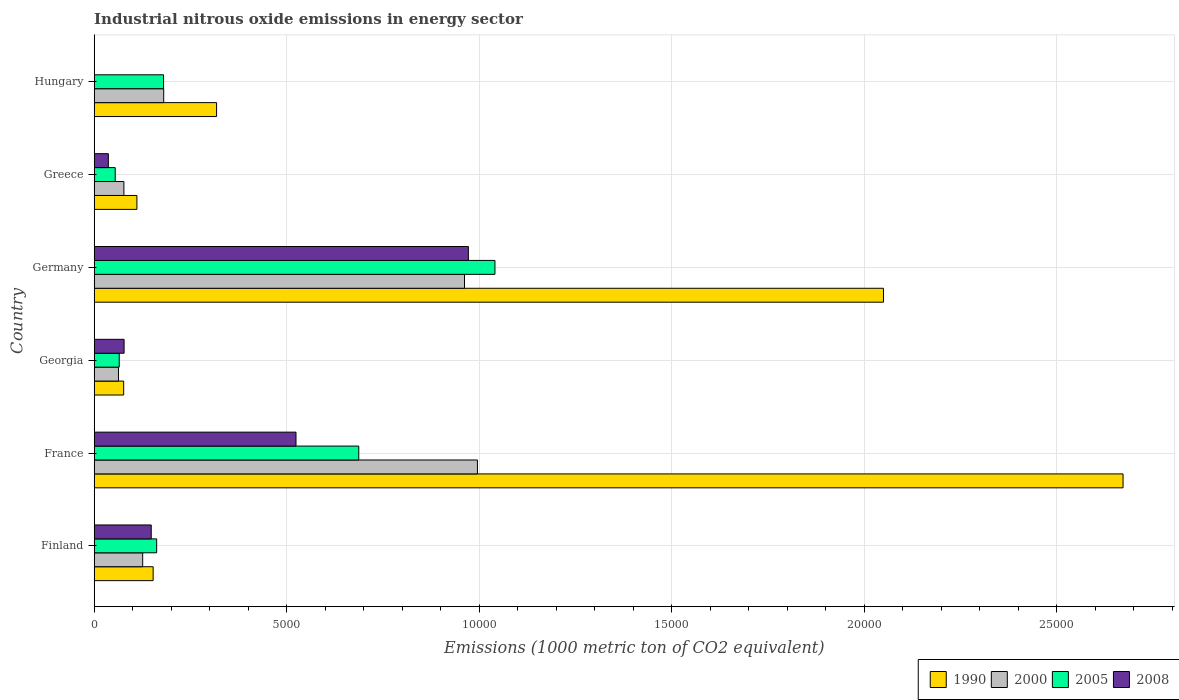Are the number of bars per tick equal to the number of legend labels?
Give a very brief answer. Yes. Are the number of bars on each tick of the Y-axis equal?
Your answer should be compact. Yes. What is the label of the 1st group of bars from the top?
Your answer should be compact. Hungary. What is the amount of industrial nitrous oxide emitted in 2005 in France?
Your answer should be compact. 6871.6. Across all countries, what is the maximum amount of industrial nitrous oxide emitted in 2008?
Make the answer very short. 9718.4. Across all countries, what is the minimum amount of industrial nitrous oxide emitted in 1990?
Provide a succinct answer. 765.3. In which country was the amount of industrial nitrous oxide emitted in 2005 maximum?
Your answer should be very brief. Germany. In which country was the amount of industrial nitrous oxide emitted in 2000 minimum?
Provide a succinct answer. Georgia. What is the total amount of industrial nitrous oxide emitted in 2005 in the graph?
Give a very brief answer. 2.19e+04. What is the difference between the amount of industrial nitrous oxide emitted in 2005 in Georgia and that in Greece?
Provide a short and direct response. 104.3. What is the difference between the amount of industrial nitrous oxide emitted in 2008 in Greece and the amount of industrial nitrous oxide emitted in 1990 in Finland?
Offer a very short reply. -1163.5. What is the average amount of industrial nitrous oxide emitted in 2000 per country?
Make the answer very short. 4006.33. What is the difference between the amount of industrial nitrous oxide emitted in 2005 and amount of industrial nitrous oxide emitted in 2008 in Finland?
Provide a short and direct response. 140.9. In how many countries, is the amount of industrial nitrous oxide emitted in 2005 greater than 26000 1000 metric ton?
Provide a short and direct response. 0. What is the ratio of the amount of industrial nitrous oxide emitted in 2008 in Finland to that in Germany?
Your response must be concise. 0.15. What is the difference between the highest and the second highest amount of industrial nitrous oxide emitted in 1990?
Give a very brief answer. 6222.7. What is the difference between the highest and the lowest amount of industrial nitrous oxide emitted in 2000?
Ensure brevity in your answer.  9323.3. What does the 2nd bar from the top in Greece represents?
Your answer should be very brief. 2005. Is it the case that in every country, the sum of the amount of industrial nitrous oxide emitted in 2005 and amount of industrial nitrous oxide emitted in 2000 is greater than the amount of industrial nitrous oxide emitted in 2008?
Your response must be concise. Yes. How many bars are there?
Offer a terse response. 24. How many countries are there in the graph?
Offer a very short reply. 6. What is the difference between two consecutive major ticks on the X-axis?
Keep it short and to the point. 5000. Does the graph contain any zero values?
Your answer should be very brief. No. Does the graph contain grids?
Provide a succinct answer. Yes. How many legend labels are there?
Your response must be concise. 4. What is the title of the graph?
Offer a terse response. Industrial nitrous oxide emissions in energy sector. What is the label or title of the X-axis?
Keep it short and to the point. Emissions (1000 metric ton of CO2 equivalent). What is the label or title of the Y-axis?
Ensure brevity in your answer.  Country. What is the Emissions (1000 metric ton of CO2 equivalent) in 1990 in Finland?
Your answer should be very brief. 1530.9. What is the Emissions (1000 metric ton of CO2 equivalent) in 2000 in Finland?
Provide a succinct answer. 1259.4. What is the Emissions (1000 metric ton of CO2 equivalent) in 2005 in Finland?
Give a very brief answer. 1622.4. What is the Emissions (1000 metric ton of CO2 equivalent) in 2008 in Finland?
Make the answer very short. 1481.5. What is the Emissions (1000 metric ton of CO2 equivalent) in 1990 in France?
Your response must be concise. 2.67e+04. What is the Emissions (1000 metric ton of CO2 equivalent) of 2000 in France?
Make the answer very short. 9953.8. What is the Emissions (1000 metric ton of CO2 equivalent) of 2005 in France?
Your response must be concise. 6871.6. What is the Emissions (1000 metric ton of CO2 equivalent) of 2008 in France?
Your answer should be compact. 5241.3. What is the Emissions (1000 metric ton of CO2 equivalent) in 1990 in Georgia?
Make the answer very short. 765.3. What is the Emissions (1000 metric ton of CO2 equivalent) in 2000 in Georgia?
Keep it short and to the point. 630.5. What is the Emissions (1000 metric ton of CO2 equivalent) of 2005 in Georgia?
Your response must be concise. 650.1. What is the Emissions (1000 metric ton of CO2 equivalent) of 2008 in Georgia?
Keep it short and to the point. 776.5. What is the Emissions (1000 metric ton of CO2 equivalent) of 1990 in Germany?
Your answer should be very brief. 2.05e+04. What is the Emissions (1000 metric ton of CO2 equivalent) in 2000 in Germany?
Offer a very short reply. 9617.9. What is the Emissions (1000 metric ton of CO2 equivalent) of 2005 in Germany?
Ensure brevity in your answer.  1.04e+04. What is the Emissions (1000 metric ton of CO2 equivalent) in 2008 in Germany?
Your answer should be compact. 9718.4. What is the Emissions (1000 metric ton of CO2 equivalent) in 1990 in Greece?
Keep it short and to the point. 1109.1. What is the Emissions (1000 metric ton of CO2 equivalent) of 2000 in Greece?
Give a very brief answer. 771. What is the Emissions (1000 metric ton of CO2 equivalent) in 2005 in Greece?
Offer a terse response. 545.8. What is the Emissions (1000 metric ton of CO2 equivalent) in 2008 in Greece?
Your answer should be very brief. 367.4. What is the Emissions (1000 metric ton of CO2 equivalent) of 1990 in Hungary?
Your answer should be compact. 3178.6. What is the Emissions (1000 metric ton of CO2 equivalent) of 2000 in Hungary?
Provide a short and direct response. 1805.4. What is the Emissions (1000 metric ton of CO2 equivalent) in 2005 in Hungary?
Your answer should be compact. 1802. What is the Emissions (1000 metric ton of CO2 equivalent) of 2008 in Hungary?
Give a very brief answer. 6. Across all countries, what is the maximum Emissions (1000 metric ton of CO2 equivalent) in 1990?
Provide a succinct answer. 2.67e+04. Across all countries, what is the maximum Emissions (1000 metric ton of CO2 equivalent) in 2000?
Provide a succinct answer. 9953.8. Across all countries, what is the maximum Emissions (1000 metric ton of CO2 equivalent) in 2005?
Make the answer very short. 1.04e+04. Across all countries, what is the maximum Emissions (1000 metric ton of CO2 equivalent) in 2008?
Make the answer very short. 9718.4. Across all countries, what is the minimum Emissions (1000 metric ton of CO2 equivalent) of 1990?
Provide a short and direct response. 765.3. Across all countries, what is the minimum Emissions (1000 metric ton of CO2 equivalent) of 2000?
Ensure brevity in your answer.  630.5. Across all countries, what is the minimum Emissions (1000 metric ton of CO2 equivalent) of 2005?
Your answer should be compact. 545.8. What is the total Emissions (1000 metric ton of CO2 equivalent) of 1990 in the graph?
Your response must be concise. 5.38e+04. What is the total Emissions (1000 metric ton of CO2 equivalent) of 2000 in the graph?
Provide a short and direct response. 2.40e+04. What is the total Emissions (1000 metric ton of CO2 equivalent) of 2005 in the graph?
Your response must be concise. 2.19e+04. What is the total Emissions (1000 metric ton of CO2 equivalent) in 2008 in the graph?
Ensure brevity in your answer.  1.76e+04. What is the difference between the Emissions (1000 metric ton of CO2 equivalent) in 1990 in Finland and that in France?
Make the answer very short. -2.52e+04. What is the difference between the Emissions (1000 metric ton of CO2 equivalent) of 2000 in Finland and that in France?
Give a very brief answer. -8694.4. What is the difference between the Emissions (1000 metric ton of CO2 equivalent) in 2005 in Finland and that in France?
Your answer should be very brief. -5249.2. What is the difference between the Emissions (1000 metric ton of CO2 equivalent) in 2008 in Finland and that in France?
Provide a succinct answer. -3759.8. What is the difference between the Emissions (1000 metric ton of CO2 equivalent) of 1990 in Finland and that in Georgia?
Ensure brevity in your answer.  765.6. What is the difference between the Emissions (1000 metric ton of CO2 equivalent) in 2000 in Finland and that in Georgia?
Provide a short and direct response. 628.9. What is the difference between the Emissions (1000 metric ton of CO2 equivalent) in 2005 in Finland and that in Georgia?
Offer a very short reply. 972.3. What is the difference between the Emissions (1000 metric ton of CO2 equivalent) of 2008 in Finland and that in Georgia?
Offer a very short reply. 705. What is the difference between the Emissions (1000 metric ton of CO2 equivalent) in 1990 in Finland and that in Germany?
Your response must be concise. -1.90e+04. What is the difference between the Emissions (1000 metric ton of CO2 equivalent) of 2000 in Finland and that in Germany?
Ensure brevity in your answer.  -8358.5. What is the difference between the Emissions (1000 metric ton of CO2 equivalent) of 2005 in Finland and that in Germany?
Your answer should be very brief. -8786.5. What is the difference between the Emissions (1000 metric ton of CO2 equivalent) in 2008 in Finland and that in Germany?
Provide a short and direct response. -8236.9. What is the difference between the Emissions (1000 metric ton of CO2 equivalent) in 1990 in Finland and that in Greece?
Offer a very short reply. 421.8. What is the difference between the Emissions (1000 metric ton of CO2 equivalent) of 2000 in Finland and that in Greece?
Make the answer very short. 488.4. What is the difference between the Emissions (1000 metric ton of CO2 equivalent) of 2005 in Finland and that in Greece?
Provide a short and direct response. 1076.6. What is the difference between the Emissions (1000 metric ton of CO2 equivalent) in 2008 in Finland and that in Greece?
Your response must be concise. 1114.1. What is the difference between the Emissions (1000 metric ton of CO2 equivalent) of 1990 in Finland and that in Hungary?
Provide a succinct answer. -1647.7. What is the difference between the Emissions (1000 metric ton of CO2 equivalent) of 2000 in Finland and that in Hungary?
Provide a succinct answer. -546. What is the difference between the Emissions (1000 metric ton of CO2 equivalent) in 2005 in Finland and that in Hungary?
Give a very brief answer. -179.6. What is the difference between the Emissions (1000 metric ton of CO2 equivalent) in 2008 in Finland and that in Hungary?
Your answer should be very brief. 1475.5. What is the difference between the Emissions (1000 metric ton of CO2 equivalent) of 1990 in France and that in Georgia?
Offer a very short reply. 2.60e+04. What is the difference between the Emissions (1000 metric ton of CO2 equivalent) of 2000 in France and that in Georgia?
Make the answer very short. 9323.3. What is the difference between the Emissions (1000 metric ton of CO2 equivalent) in 2005 in France and that in Georgia?
Make the answer very short. 6221.5. What is the difference between the Emissions (1000 metric ton of CO2 equivalent) in 2008 in France and that in Georgia?
Your answer should be very brief. 4464.8. What is the difference between the Emissions (1000 metric ton of CO2 equivalent) in 1990 in France and that in Germany?
Your answer should be very brief. 6222.7. What is the difference between the Emissions (1000 metric ton of CO2 equivalent) in 2000 in France and that in Germany?
Your answer should be compact. 335.9. What is the difference between the Emissions (1000 metric ton of CO2 equivalent) of 2005 in France and that in Germany?
Keep it short and to the point. -3537.3. What is the difference between the Emissions (1000 metric ton of CO2 equivalent) in 2008 in France and that in Germany?
Make the answer very short. -4477.1. What is the difference between the Emissions (1000 metric ton of CO2 equivalent) in 1990 in France and that in Greece?
Ensure brevity in your answer.  2.56e+04. What is the difference between the Emissions (1000 metric ton of CO2 equivalent) of 2000 in France and that in Greece?
Ensure brevity in your answer.  9182.8. What is the difference between the Emissions (1000 metric ton of CO2 equivalent) of 2005 in France and that in Greece?
Keep it short and to the point. 6325.8. What is the difference between the Emissions (1000 metric ton of CO2 equivalent) in 2008 in France and that in Greece?
Offer a very short reply. 4873.9. What is the difference between the Emissions (1000 metric ton of CO2 equivalent) in 1990 in France and that in Hungary?
Your answer should be very brief. 2.35e+04. What is the difference between the Emissions (1000 metric ton of CO2 equivalent) of 2000 in France and that in Hungary?
Keep it short and to the point. 8148.4. What is the difference between the Emissions (1000 metric ton of CO2 equivalent) of 2005 in France and that in Hungary?
Your response must be concise. 5069.6. What is the difference between the Emissions (1000 metric ton of CO2 equivalent) in 2008 in France and that in Hungary?
Offer a very short reply. 5235.3. What is the difference between the Emissions (1000 metric ton of CO2 equivalent) of 1990 in Georgia and that in Germany?
Give a very brief answer. -1.97e+04. What is the difference between the Emissions (1000 metric ton of CO2 equivalent) of 2000 in Georgia and that in Germany?
Provide a succinct answer. -8987.4. What is the difference between the Emissions (1000 metric ton of CO2 equivalent) of 2005 in Georgia and that in Germany?
Offer a very short reply. -9758.8. What is the difference between the Emissions (1000 metric ton of CO2 equivalent) in 2008 in Georgia and that in Germany?
Give a very brief answer. -8941.9. What is the difference between the Emissions (1000 metric ton of CO2 equivalent) in 1990 in Georgia and that in Greece?
Your response must be concise. -343.8. What is the difference between the Emissions (1000 metric ton of CO2 equivalent) in 2000 in Georgia and that in Greece?
Give a very brief answer. -140.5. What is the difference between the Emissions (1000 metric ton of CO2 equivalent) in 2005 in Georgia and that in Greece?
Ensure brevity in your answer.  104.3. What is the difference between the Emissions (1000 metric ton of CO2 equivalent) in 2008 in Georgia and that in Greece?
Your answer should be compact. 409.1. What is the difference between the Emissions (1000 metric ton of CO2 equivalent) in 1990 in Georgia and that in Hungary?
Your answer should be compact. -2413.3. What is the difference between the Emissions (1000 metric ton of CO2 equivalent) in 2000 in Georgia and that in Hungary?
Make the answer very short. -1174.9. What is the difference between the Emissions (1000 metric ton of CO2 equivalent) of 2005 in Georgia and that in Hungary?
Offer a terse response. -1151.9. What is the difference between the Emissions (1000 metric ton of CO2 equivalent) of 2008 in Georgia and that in Hungary?
Provide a short and direct response. 770.5. What is the difference between the Emissions (1000 metric ton of CO2 equivalent) of 1990 in Germany and that in Greece?
Offer a very short reply. 1.94e+04. What is the difference between the Emissions (1000 metric ton of CO2 equivalent) of 2000 in Germany and that in Greece?
Your answer should be very brief. 8846.9. What is the difference between the Emissions (1000 metric ton of CO2 equivalent) of 2005 in Germany and that in Greece?
Ensure brevity in your answer.  9863.1. What is the difference between the Emissions (1000 metric ton of CO2 equivalent) in 2008 in Germany and that in Greece?
Your response must be concise. 9351. What is the difference between the Emissions (1000 metric ton of CO2 equivalent) of 1990 in Germany and that in Hungary?
Ensure brevity in your answer.  1.73e+04. What is the difference between the Emissions (1000 metric ton of CO2 equivalent) in 2000 in Germany and that in Hungary?
Your response must be concise. 7812.5. What is the difference between the Emissions (1000 metric ton of CO2 equivalent) of 2005 in Germany and that in Hungary?
Your answer should be very brief. 8606.9. What is the difference between the Emissions (1000 metric ton of CO2 equivalent) in 2008 in Germany and that in Hungary?
Provide a succinct answer. 9712.4. What is the difference between the Emissions (1000 metric ton of CO2 equivalent) in 1990 in Greece and that in Hungary?
Make the answer very short. -2069.5. What is the difference between the Emissions (1000 metric ton of CO2 equivalent) in 2000 in Greece and that in Hungary?
Provide a succinct answer. -1034.4. What is the difference between the Emissions (1000 metric ton of CO2 equivalent) of 2005 in Greece and that in Hungary?
Provide a short and direct response. -1256.2. What is the difference between the Emissions (1000 metric ton of CO2 equivalent) of 2008 in Greece and that in Hungary?
Provide a short and direct response. 361.4. What is the difference between the Emissions (1000 metric ton of CO2 equivalent) in 1990 in Finland and the Emissions (1000 metric ton of CO2 equivalent) in 2000 in France?
Keep it short and to the point. -8422.9. What is the difference between the Emissions (1000 metric ton of CO2 equivalent) of 1990 in Finland and the Emissions (1000 metric ton of CO2 equivalent) of 2005 in France?
Ensure brevity in your answer.  -5340.7. What is the difference between the Emissions (1000 metric ton of CO2 equivalent) in 1990 in Finland and the Emissions (1000 metric ton of CO2 equivalent) in 2008 in France?
Ensure brevity in your answer.  -3710.4. What is the difference between the Emissions (1000 metric ton of CO2 equivalent) of 2000 in Finland and the Emissions (1000 metric ton of CO2 equivalent) of 2005 in France?
Your answer should be very brief. -5612.2. What is the difference between the Emissions (1000 metric ton of CO2 equivalent) in 2000 in Finland and the Emissions (1000 metric ton of CO2 equivalent) in 2008 in France?
Your answer should be compact. -3981.9. What is the difference between the Emissions (1000 metric ton of CO2 equivalent) of 2005 in Finland and the Emissions (1000 metric ton of CO2 equivalent) of 2008 in France?
Your response must be concise. -3618.9. What is the difference between the Emissions (1000 metric ton of CO2 equivalent) of 1990 in Finland and the Emissions (1000 metric ton of CO2 equivalent) of 2000 in Georgia?
Offer a terse response. 900.4. What is the difference between the Emissions (1000 metric ton of CO2 equivalent) in 1990 in Finland and the Emissions (1000 metric ton of CO2 equivalent) in 2005 in Georgia?
Your response must be concise. 880.8. What is the difference between the Emissions (1000 metric ton of CO2 equivalent) in 1990 in Finland and the Emissions (1000 metric ton of CO2 equivalent) in 2008 in Georgia?
Your response must be concise. 754.4. What is the difference between the Emissions (1000 metric ton of CO2 equivalent) in 2000 in Finland and the Emissions (1000 metric ton of CO2 equivalent) in 2005 in Georgia?
Your answer should be compact. 609.3. What is the difference between the Emissions (1000 metric ton of CO2 equivalent) of 2000 in Finland and the Emissions (1000 metric ton of CO2 equivalent) of 2008 in Georgia?
Keep it short and to the point. 482.9. What is the difference between the Emissions (1000 metric ton of CO2 equivalent) in 2005 in Finland and the Emissions (1000 metric ton of CO2 equivalent) in 2008 in Georgia?
Provide a succinct answer. 845.9. What is the difference between the Emissions (1000 metric ton of CO2 equivalent) in 1990 in Finland and the Emissions (1000 metric ton of CO2 equivalent) in 2000 in Germany?
Offer a terse response. -8087. What is the difference between the Emissions (1000 metric ton of CO2 equivalent) in 1990 in Finland and the Emissions (1000 metric ton of CO2 equivalent) in 2005 in Germany?
Ensure brevity in your answer.  -8878. What is the difference between the Emissions (1000 metric ton of CO2 equivalent) of 1990 in Finland and the Emissions (1000 metric ton of CO2 equivalent) of 2008 in Germany?
Give a very brief answer. -8187.5. What is the difference between the Emissions (1000 metric ton of CO2 equivalent) in 2000 in Finland and the Emissions (1000 metric ton of CO2 equivalent) in 2005 in Germany?
Provide a succinct answer. -9149.5. What is the difference between the Emissions (1000 metric ton of CO2 equivalent) in 2000 in Finland and the Emissions (1000 metric ton of CO2 equivalent) in 2008 in Germany?
Your answer should be very brief. -8459. What is the difference between the Emissions (1000 metric ton of CO2 equivalent) in 2005 in Finland and the Emissions (1000 metric ton of CO2 equivalent) in 2008 in Germany?
Provide a succinct answer. -8096. What is the difference between the Emissions (1000 metric ton of CO2 equivalent) of 1990 in Finland and the Emissions (1000 metric ton of CO2 equivalent) of 2000 in Greece?
Ensure brevity in your answer.  759.9. What is the difference between the Emissions (1000 metric ton of CO2 equivalent) of 1990 in Finland and the Emissions (1000 metric ton of CO2 equivalent) of 2005 in Greece?
Offer a very short reply. 985.1. What is the difference between the Emissions (1000 metric ton of CO2 equivalent) of 1990 in Finland and the Emissions (1000 metric ton of CO2 equivalent) of 2008 in Greece?
Your answer should be compact. 1163.5. What is the difference between the Emissions (1000 metric ton of CO2 equivalent) in 2000 in Finland and the Emissions (1000 metric ton of CO2 equivalent) in 2005 in Greece?
Your response must be concise. 713.6. What is the difference between the Emissions (1000 metric ton of CO2 equivalent) of 2000 in Finland and the Emissions (1000 metric ton of CO2 equivalent) of 2008 in Greece?
Provide a succinct answer. 892. What is the difference between the Emissions (1000 metric ton of CO2 equivalent) of 2005 in Finland and the Emissions (1000 metric ton of CO2 equivalent) of 2008 in Greece?
Keep it short and to the point. 1255. What is the difference between the Emissions (1000 metric ton of CO2 equivalent) in 1990 in Finland and the Emissions (1000 metric ton of CO2 equivalent) in 2000 in Hungary?
Offer a terse response. -274.5. What is the difference between the Emissions (1000 metric ton of CO2 equivalent) of 1990 in Finland and the Emissions (1000 metric ton of CO2 equivalent) of 2005 in Hungary?
Your response must be concise. -271.1. What is the difference between the Emissions (1000 metric ton of CO2 equivalent) in 1990 in Finland and the Emissions (1000 metric ton of CO2 equivalent) in 2008 in Hungary?
Provide a short and direct response. 1524.9. What is the difference between the Emissions (1000 metric ton of CO2 equivalent) of 2000 in Finland and the Emissions (1000 metric ton of CO2 equivalent) of 2005 in Hungary?
Your response must be concise. -542.6. What is the difference between the Emissions (1000 metric ton of CO2 equivalent) of 2000 in Finland and the Emissions (1000 metric ton of CO2 equivalent) of 2008 in Hungary?
Offer a terse response. 1253.4. What is the difference between the Emissions (1000 metric ton of CO2 equivalent) in 2005 in Finland and the Emissions (1000 metric ton of CO2 equivalent) in 2008 in Hungary?
Your answer should be compact. 1616.4. What is the difference between the Emissions (1000 metric ton of CO2 equivalent) in 1990 in France and the Emissions (1000 metric ton of CO2 equivalent) in 2000 in Georgia?
Your response must be concise. 2.61e+04. What is the difference between the Emissions (1000 metric ton of CO2 equivalent) of 1990 in France and the Emissions (1000 metric ton of CO2 equivalent) of 2005 in Georgia?
Provide a short and direct response. 2.61e+04. What is the difference between the Emissions (1000 metric ton of CO2 equivalent) in 1990 in France and the Emissions (1000 metric ton of CO2 equivalent) in 2008 in Georgia?
Provide a short and direct response. 2.59e+04. What is the difference between the Emissions (1000 metric ton of CO2 equivalent) in 2000 in France and the Emissions (1000 metric ton of CO2 equivalent) in 2005 in Georgia?
Keep it short and to the point. 9303.7. What is the difference between the Emissions (1000 metric ton of CO2 equivalent) of 2000 in France and the Emissions (1000 metric ton of CO2 equivalent) of 2008 in Georgia?
Your answer should be very brief. 9177.3. What is the difference between the Emissions (1000 metric ton of CO2 equivalent) of 2005 in France and the Emissions (1000 metric ton of CO2 equivalent) of 2008 in Georgia?
Your response must be concise. 6095.1. What is the difference between the Emissions (1000 metric ton of CO2 equivalent) of 1990 in France and the Emissions (1000 metric ton of CO2 equivalent) of 2000 in Germany?
Your response must be concise. 1.71e+04. What is the difference between the Emissions (1000 metric ton of CO2 equivalent) in 1990 in France and the Emissions (1000 metric ton of CO2 equivalent) in 2005 in Germany?
Offer a very short reply. 1.63e+04. What is the difference between the Emissions (1000 metric ton of CO2 equivalent) in 1990 in France and the Emissions (1000 metric ton of CO2 equivalent) in 2008 in Germany?
Your response must be concise. 1.70e+04. What is the difference between the Emissions (1000 metric ton of CO2 equivalent) of 2000 in France and the Emissions (1000 metric ton of CO2 equivalent) of 2005 in Germany?
Offer a very short reply. -455.1. What is the difference between the Emissions (1000 metric ton of CO2 equivalent) of 2000 in France and the Emissions (1000 metric ton of CO2 equivalent) of 2008 in Germany?
Give a very brief answer. 235.4. What is the difference between the Emissions (1000 metric ton of CO2 equivalent) of 2005 in France and the Emissions (1000 metric ton of CO2 equivalent) of 2008 in Germany?
Offer a terse response. -2846.8. What is the difference between the Emissions (1000 metric ton of CO2 equivalent) in 1990 in France and the Emissions (1000 metric ton of CO2 equivalent) in 2000 in Greece?
Keep it short and to the point. 2.60e+04. What is the difference between the Emissions (1000 metric ton of CO2 equivalent) of 1990 in France and the Emissions (1000 metric ton of CO2 equivalent) of 2005 in Greece?
Your answer should be compact. 2.62e+04. What is the difference between the Emissions (1000 metric ton of CO2 equivalent) of 1990 in France and the Emissions (1000 metric ton of CO2 equivalent) of 2008 in Greece?
Make the answer very short. 2.64e+04. What is the difference between the Emissions (1000 metric ton of CO2 equivalent) of 2000 in France and the Emissions (1000 metric ton of CO2 equivalent) of 2005 in Greece?
Ensure brevity in your answer.  9408. What is the difference between the Emissions (1000 metric ton of CO2 equivalent) of 2000 in France and the Emissions (1000 metric ton of CO2 equivalent) of 2008 in Greece?
Your answer should be compact. 9586.4. What is the difference between the Emissions (1000 metric ton of CO2 equivalent) of 2005 in France and the Emissions (1000 metric ton of CO2 equivalent) of 2008 in Greece?
Provide a short and direct response. 6504.2. What is the difference between the Emissions (1000 metric ton of CO2 equivalent) in 1990 in France and the Emissions (1000 metric ton of CO2 equivalent) in 2000 in Hungary?
Your response must be concise. 2.49e+04. What is the difference between the Emissions (1000 metric ton of CO2 equivalent) in 1990 in France and the Emissions (1000 metric ton of CO2 equivalent) in 2005 in Hungary?
Your answer should be very brief. 2.49e+04. What is the difference between the Emissions (1000 metric ton of CO2 equivalent) in 1990 in France and the Emissions (1000 metric ton of CO2 equivalent) in 2008 in Hungary?
Your answer should be very brief. 2.67e+04. What is the difference between the Emissions (1000 metric ton of CO2 equivalent) of 2000 in France and the Emissions (1000 metric ton of CO2 equivalent) of 2005 in Hungary?
Offer a very short reply. 8151.8. What is the difference between the Emissions (1000 metric ton of CO2 equivalent) of 2000 in France and the Emissions (1000 metric ton of CO2 equivalent) of 2008 in Hungary?
Provide a short and direct response. 9947.8. What is the difference between the Emissions (1000 metric ton of CO2 equivalent) of 2005 in France and the Emissions (1000 metric ton of CO2 equivalent) of 2008 in Hungary?
Your answer should be compact. 6865.6. What is the difference between the Emissions (1000 metric ton of CO2 equivalent) of 1990 in Georgia and the Emissions (1000 metric ton of CO2 equivalent) of 2000 in Germany?
Your answer should be compact. -8852.6. What is the difference between the Emissions (1000 metric ton of CO2 equivalent) of 1990 in Georgia and the Emissions (1000 metric ton of CO2 equivalent) of 2005 in Germany?
Ensure brevity in your answer.  -9643.6. What is the difference between the Emissions (1000 metric ton of CO2 equivalent) of 1990 in Georgia and the Emissions (1000 metric ton of CO2 equivalent) of 2008 in Germany?
Offer a terse response. -8953.1. What is the difference between the Emissions (1000 metric ton of CO2 equivalent) in 2000 in Georgia and the Emissions (1000 metric ton of CO2 equivalent) in 2005 in Germany?
Ensure brevity in your answer.  -9778.4. What is the difference between the Emissions (1000 metric ton of CO2 equivalent) in 2000 in Georgia and the Emissions (1000 metric ton of CO2 equivalent) in 2008 in Germany?
Give a very brief answer. -9087.9. What is the difference between the Emissions (1000 metric ton of CO2 equivalent) in 2005 in Georgia and the Emissions (1000 metric ton of CO2 equivalent) in 2008 in Germany?
Your answer should be compact. -9068.3. What is the difference between the Emissions (1000 metric ton of CO2 equivalent) in 1990 in Georgia and the Emissions (1000 metric ton of CO2 equivalent) in 2000 in Greece?
Ensure brevity in your answer.  -5.7. What is the difference between the Emissions (1000 metric ton of CO2 equivalent) in 1990 in Georgia and the Emissions (1000 metric ton of CO2 equivalent) in 2005 in Greece?
Keep it short and to the point. 219.5. What is the difference between the Emissions (1000 metric ton of CO2 equivalent) in 1990 in Georgia and the Emissions (1000 metric ton of CO2 equivalent) in 2008 in Greece?
Offer a very short reply. 397.9. What is the difference between the Emissions (1000 metric ton of CO2 equivalent) of 2000 in Georgia and the Emissions (1000 metric ton of CO2 equivalent) of 2005 in Greece?
Your answer should be very brief. 84.7. What is the difference between the Emissions (1000 metric ton of CO2 equivalent) of 2000 in Georgia and the Emissions (1000 metric ton of CO2 equivalent) of 2008 in Greece?
Keep it short and to the point. 263.1. What is the difference between the Emissions (1000 metric ton of CO2 equivalent) of 2005 in Georgia and the Emissions (1000 metric ton of CO2 equivalent) of 2008 in Greece?
Offer a very short reply. 282.7. What is the difference between the Emissions (1000 metric ton of CO2 equivalent) of 1990 in Georgia and the Emissions (1000 metric ton of CO2 equivalent) of 2000 in Hungary?
Your answer should be very brief. -1040.1. What is the difference between the Emissions (1000 metric ton of CO2 equivalent) in 1990 in Georgia and the Emissions (1000 metric ton of CO2 equivalent) in 2005 in Hungary?
Keep it short and to the point. -1036.7. What is the difference between the Emissions (1000 metric ton of CO2 equivalent) of 1990 in Georgia and the Emissions (1000 metric ton of CO2 equivalent) of 2008 in Hungary?
Make the answer very short. 759.3. What is the difference between the Emissions (1000 metric ton of CO2 equivalent) of 2000 in Georgia and the Emissions (1000 metric ton of CO2 equivalent) of 2005 in Hungary?
Provide a succinct answer. -1171.5. What is the difference between the Emissions (1000 metric ton of CO2 equivalent) in 2000 in Georgia and the Emissions (1000 metric ton of CO2 equivalent) in 2008 in Hungary?
Your answer should be compact. 624.5. What is the difference between the Emissions (1000 metric ton of CO2 equivalent) in 2005 in Georgia and the Emissions (1000 metric ton of CO2 equivalent) in 2008 in Hungary?
Offer a very short reply. 644.1. What is the difference between the Emissions (1000 metric ton of CO2 equivalent) in 1990 in Germany and the Emissions (1000 metric ton of CO2 equivalent) in 2000 in Greece?
Provide a succinct answer. 1.97e+04. What is the difference between the Emissions (1000 metric ton of CO2 equivalent) in 1990 in Germany and the Emissions (1000 metric ton of CO2 equivalent) in 2005 in Greece?
Keep it short and to the point. 2.00e+04. What is the difference between the Emissions (1000 metric ton of CO2 equivalent) in 1990 in Germany and the Emissions (1000 metric ton of CO2 equivalent) in 2008 in Greece?
Ensure brevity in your answer.  2.01e+04. What is the difference between the Emissions (1000 metric ton of CO2 equivalent) in 2000 in Germany and the Emissions (1000 metric ton of CO2 equivalent) in 2005 in Greece?
Offer a very short reply. 9072.1. What is the difference between the Emissions (1000 metric ton of CO2 equivalent) in 2000 in Germany and the Emissions (1000 metric ton of CO2 equivalent) in 2008 in Greece?
Ensure brevity in your answer.  9250.5. What is the difference between the Emissions (1000 metric ton of CO2 equivalent) of 2005 in Germany and the Emissions (1000 metric ton of CO2 equivalent) of 2008 in Greece?
Provide a short and direct response. 1.00e+04. What is the difference between the Emissions (1000 metric ton of CO2 equivalent) of 1990 in Germany and the Emissions (1000 metric ton of CO2 equivalent) of 2000 in Hungary?
Provide a succinct answer. 1.87e+04. What is the difference between the Emissions (1000 metric ton of CO2 equivalent) in 1990 in Germany and the Emissions (1000 metric ton of CO2 equivalent) in 2005 in Hungary?
Your response must be concise. 1.87e+04. What is the difference between the Emissions (1000 metric ton of CO2 equivalent) in 1990 in Germany and the Emissions (1000 metric ton of CO2 equivalent) in 2008 in Hungary?
Offer a very short reply. 2.05e+04. What is the difference between the Emissions (1000 metric ton of CO2 equivalent) in 2000 in Germany and the Emissions (1000 metric ton of CO2 equivalent) in 2005 in Hungary?
Keep it short and to the point. 7815.9. What is the difference between the Emissions (1000 metric ton of CO2 equivalent) in 2000 in Germany and the Emissions (1000 metric ton of CO2 equivalent) in 2008 in Hungary?
Provide a succinct answer. 9611.9. What is the difference between the Emissions (1000 metric ton of CO2 equivalent) in 2005 in Germany and the Emissions (1000 metric ton of CO2 equivalent) in 2008 in Hungary?
Your answer should be compact. 1.04e+04. What is the difference between the Emissions (1000 metric ton of CO2 equivalent) in 1990 in Greece and the Emissions (1000 metric ton of CO2 equivalent) in 2000 in Hungary?
Your answer should be very brief. -696.3. What is the difference between the Emissions (1000 metric ton of CO2 equivalent) in 1990 in Greece and the Emissions (1000 metric ton of CO2 equivalent) in 2005 in Hungary?
Your answer should be compact. -692.9. What is the difference between the Emissions (1000 metric ton of CO2 equivalent) of 1990 in Greece and the Emissions (1000 metric ton of CO2 equivalent) of 2008 in Hungary?
Make the answer very short. 1103.1. What is the difference between the Emissions (1000 metric ton of CO2 equivalent) of 2000 in Greece and the Emissions (1000 metric ton of CO2 equivalent) of 2005 in Hungary?
Your response must be concise. -1031. What is the difference between the Emissions (1000 metric ton of CO2 equivalent) in 2000 in Greece and the Emissions (1000 metric ton of CO2 equivalent) in 2008 in Hungary?
Offer a terse response. 765. What is the difference between the Emissions (1000 metric ton of CO2 equivalent) of 2005 in Greece and the Emissions (1000 metric ton of CO2 equivalent) of 2008 in Hungary?
Give a very brief answer. 539.8. What is the average Emissions (1000 metric ton of CO2 equivalent) in 1990 per country?
Your answer should be compact. 8967.63. What is the average Emissions (1000 metric ton of CO2 equivalent) in 2000 per country?
Your answer should be compact. 4006.33. What is the average Emissions (1000 metric ton of CO2 equivalent) of 2005 per country?
Give a very brief answer. 3650.13. What is the average Emissions (1000 metric ton of CO2 equivalent) in 2008 per country?
Offer a terse response. 2931.85. What is the difference between the Emissions (1000 metric ton of CO2 equivalent) of 1990 and Emissions (1000 metric ton of CO2 equivalent) of 2000 in Finland?
Provide a short and direct response. 271.5. What is the difference between the Emissions (1000 metric ton of CO2 equivalent) of 1990 and Emissions (1000 metric ton of CO2 equivalent) of 2005 in Finland?
Your answer should be very brief. -91.5. What is the difference between the Emissions (1000 metric ton of CO2 equivalent) of 1990 and Emissions (1000 metric ton of CO2 equivalent) of 2008 in Finland?
Keep it short and to the point. 49.4. What is the difference between the Emissions (1000 metric ton of CO2 equivalent) in 2000 and Emissions (1000 metric ton of CO2 equivalent) in 2005 in Finland?
Give a very brief answer. -363. What is the difference between the Emissions (1000 metric ton of CO2 equivalent) of 2000 and Emissions (1000 metric ton of CO2 equivalent) of 2008 in Finland?
Offer a terse response. -222.1. What is the difference between the Emissions (1000 metric ton of CO2 equivalent) of 2005 and Emissions (1000 metric ton of CO2 equivalent) of 2008 in Finland?
Your response must be concise. 140.9. What is the difference between the Emissions (1000 metric ton of CO2 equivalent) of 1990 and Emissions (1000 metric ton of CO2 equivalent) of 2000 in France?
Make the answer very short. 1.68e+04. What is the difference between the Emissions (1000 metric ton of CO2 equivalent) in 1990 and Emissions (1000 metric ton of CO2 equivalent) in 2005 in France?
Your answer should be compact. 1.99e+04. What is the difference between the Emissions (1000 metric ton of CO2 equivalent) in 1990 and Emissions (1000 metric ton of CO2 equivalent) in 2008 in France?
Make the answer very short. 2.15e+04. What is the difference between the Emissions (1000 metric ton of CO2 equivalent) in 2000 and Emissions (1000 metric ton of CO2 equivalent) in 2005 in France?
Offer a very short reply. 3082.2. What is the difference between the Emissions (1000 metric ton of CO2 equivalent) in 2000 and Emissions (1000 metric ton of CO2 equivalent) in 2008 in France?
Make the answer very short. 4712.5. What is the difference between the Emissions (1000 metric ton of CO2 equivalent) in 2005 and Emissions (1000 metric ton of CO2 equivalent) in 2008 in France?
Offer a very short reply. 1630.3. What is the difference between the Emissions (1000 metric ton of CO2 equivalent) of 1990 and Emissions (1000 metric ton of CO2 equivalent) of 2000 in Georgia?
Provide a succinct answer. 134.8. What is the difference between the Emissions (1000 metric ton of CO2 equivalent) in 1990 and Emissions (1000 metric ton of CO2 equivalent) in 2005 in Georgia?
Make the answer very short. 115.2. What is the difference between the Emissions (1000 metric ton of CO2 equivalent) in 1990 and Emissions (1000 metric ton of CO2 equivalent) in 2008 in Georgia?
Your response must be concise. -11.2. What is the difference between the Emissions (1000 metric ton of CO2 equivalent) of 2000 and Emissions (1000 metric ton of CO2 equivalent) of 2005 in Georgia?
Your response must be concise. -19.6. What is the difference between the Emissions (1000 metric ton of CO2 equivalent) of 2000 and Emissions (1000 metric ton of CO2 equivalent) of 2008 in Georgia?
Your answer should be compact. -146. What is the difference between the Emissions (1000 metric ton of CO2 equivalent) of 2005 and Emissions (1000 metric ton of CO2 equivalent) of 2008 in Georgia?
Offer a very short reply. -126.4. What is the difference between the Emissions (1000 metric ton of CO2 equivalent) in 1990 and Emissions (1000 metric ton of CO2 equivalent) in 2000 in Germany?
Offer a terse response. 1.09e+04. What is the difference between the Emissions (1000 metric ton of CO2 equivalent) of 1990 and Emissions (1000 metric ton of CO2 equivalent) of 2005 in Germany?
Keep it short and to the point. 1.01e+04. What is the difference between the Emissions (1000 metric ton of CO2 equivalent) in 1990 and Emissions (1000 metric ton of CO2 equivalent) in 2008 in Germany?
Your answer should be compact. 1.08e+04. What is the difference between the Emissions (1000 metric ton of CO2 equivalent) of 2000 and Emissions (1000 metric ton of CO2 equivalent) of 2005 in Germany?
Keep it short and to the point. -791. What is the difference between the Emissions (1000 metric ton of CO2 equivalent) of 2000 and Emissions (1000 metric ton of CO2 equivalent) of 2008 in Germany?
Your answer should be compact. -100.5. What is the difference between the Emissions (1000 metric ton of CO2 equivalent) of 2005 and Emissions (1000 metric ton of CO2 equivalent) of 2008 in Germany?
Offer a terse response. 690.5. What is the difference between the Emissions (1000 metric ton of CO2 equivalent) in 1990 and Emissions (1000 metric ton of CO2 equivalent) in 2000 in Greece?
Your response must be concise. 338.1. What is the difference between the Emissions (1000 metric ton of CO2 equivalent) of 1990 and Emissions (1000 metric ton of CO2 equivalent) of 2005 in Greece?
Ensure brevity in your answer.  563.3. What is the difference between the Emissions (1000 metric ton of CO2 equivalent) of 1990 and Emissions (1000 metric ton of CO2 equivalent) of 2008 in Greece?
Make the answer very short. 741.7. What is the difference between the Emissions (1000 metric ton of CO2 equivalent) in 2000 and Emissions (1000 metric ton of CO2 equivalent) in 2005 in Greece?
Your response must be concise. 225.2. What is the difference between the Emissions (1000 metric ton of CO2 equivalent) of 2000 and Emissions (1000 metric ton of CO2 equivalent) of 2008 in Greece?
Your response must be concise. 403.6. What is the difference between the Emissions (1000 metric ton of CO2 equivalent) in 2005 and Emissions (1000 metric ton of CO2 equivalent) in 2008 in Greece?
Offer a terse response. 178.4. What is the difference between the Emissions (1000 metric ton of CO2 equivalent) of 1990 and Emissions (1000 metric ton of CO2 equivalent) of 2000 in Hungary?
Keep it short and to the point. 1373.2. What is the difference between the Emissions (1000 metric ton of CO2 equivalent) in 1990 and Emissions (1000 metric ton of CO2 equivalent) in 2005 in Hungary?
Provide a short and direct response. 1376.6. What is the difference between the Emissions (1000 metric ton of CO2 equivalent) in 1990 and Emissions (1000 metric ton of CO2 equivalent) in 2008 in Hungary?
Offer a terse response. 3172.6. What is the difference between the Emissions (1000 metric ton of CO2 equivalent) in 2000 and Emissions (1000 metric ton of CO2 equivalent) in 2005 in Hungary?
Your response must be concise. 3.4. What is the difference between the Emissions (1000 metric ton of CO2 equivalent) in 2000 and Emissions (1000 metric ton of CO2 equivalent) in 2008 in Hungary?
Provide a short and direct response. 1799.4. What is the difference between the Emissions (1000 metric ton of CO2 equivalent) of 2005 and Emissions (1000 metric ton of CO2 equivalent) of 2008 in Hungary?
Keep it short and to the point. 1796. What is the ratio of the Emissions (1000 metric ton of CO2 equivalent) in 1990 in Finland to that in France?
Offer a very short reply. 0.06. What is the ratio of the Emissions (1000 metric ton of CO2 equivalent) in 2000 in Finland to that in France?
Ensure brevity in your answer.  0.13. What is the ratio of the Emissions (1000 metric ton of CO2 equivalent) of 2005 in Finland to that in France?
Your response must be concise. 0.24. What is the ratio of the Emissions (1000 metric ton of CO2 equivalent) in 2008 in Finland to that in France?
Offer a very short reply. 0.28. What is the ratio of the Emissions (1000 metric ton of CO2 equivalent) in 1990 in Finland to that in Georgia?
Provide a short and direct response. 2. What is the ratio of the Emissions (1000 metric ton of CO2 equivalent) of 2000 in Finland to that in Georgia?
Your response must be concise. 2. What is the ratio of the Emissions (1000 metric ton of CO2 equivalent) in 2005 in Finland to that in Georgia?
Provide a succinct answer. 2.5. What is the ratio of the Emissions (1000 metric ton of CO2 equivalent) in 2008 in Finland to that in Georgia?
Your response must be concise. 1.91. What is the ratio of the Emissions (1000 metric ton of CO2 equivalent) in 1990 in Finland to that in Germany?
Keep it short and to the point. 0.07. What is the ratio of the Emissions (1000 metric ton of CO2 equivalent) of 2000 in Finland to that in Germany?
Provide a short and direct response. 0.13. What is the ratio of the Emissions (1000 metric ton of CO2 equivalent) of 2005 in Finland to that in Germany?
Ensure brevity in your answer.  0.16. What is the ratio of the Emissions (1000 metric ton of CO2 equivalent) of 2008 in Finland to that in Germany?
Your answer should be compact. 0.15. What is the ratio of the Emissions (1000 metric ton of CO2 equivalent) of 1990 in Finland to that in Greece?
Make the answer very short. 1.38. What is the ratio of the Emissions (1000 metric ton of CO2 equivalent) of 2000 in Finland to that in Greece?
Make the answer very short. 1.63. What is the ratio of the Emissions (1000 metric ton of CO2 equivalent) of 2005 in Finland to that in Greece?
Ensure brevity in your answer.  2.97. What is the ratio of the Emissions (1000 metric ton of CO2 equivalent) in 2008 in Finland to that in Greece?
Your response must be concise. 4.03. What is the ratio of the Emissions (1000 metric ton of CO2 equivalent) in 1990 in Finland to that in Hungary?
Offer a terse response. 0.48. What is the ratio of the Emissions (1000 metric ton of CO2 equivalent) of 2000 in Finland to that in Hungary?
Your answer should be very brief. 0.7. What is the ratio of the Emissions (1000 metric ton of CO2 equivalent) in 2005 in Finland to that in Hungary?
Offer a very short reply. 0.9. What is the ratio of the Emissions (1000 metric ton of CO2 equivalent) of 2008 in Finland to that in Hungary?
Provide a short and direct response. 246.92. What is the ratio of the Emissions (1000 metric ton of CO2 equivalent) of 1990 in France to that in Georgia?
Provide a succinct answer. 34.92. What is the ratio of the Emissions (1000 metric ton of CO2 equivalent) of 2000 in France to that in Georgia?
Offer a terse response. 15.79. What is the ratio of the Emissions (1000 metric ton of CO2 equivalent) in 2005 in France to that in Georgia?
Your answer should be compact. 10.57. What is the ratio of the Emissions (1000 metric ton of CO2 equivalent) of 2008 in France to that in Georgia?
Your answer should be very brief. 6.75. What is the ratio of the Emissions (1000 metric ton of CO2 equivalent) in 1990 in France to that in Germany?
Offer a terse response. 1.3. What is the ratio of the Emissions (1000 metric ton of CO2 equivalent) in 2000 in France to that in Germany?
Keep it short and to the point. 1.03. What is the ratio of the Emissions (1000 metric ton of CO2 equivalent) of 2005 in France to that in Germany?
Your response must be concise. 0.66. What is the ratio of the Emissions (1000 metric ton of CO2 equivalent) in 2008 in France to that in Germany?
Offer a very short reply. 0.54. What is the ratio of the Emissions (1000 metric ton of CO2 equivalent) of 1990 in France to that in Greece?
Your answer should be very brief. 24.09. What is the ratio of the Emissions (1000 metric ton of CO2 equivalent) of 2000 in France to that in Greece?
Provide a succinct answer. 12.91. What is the ratio of the Emissions (1000 metric ton of CO2 equivalent) in 2005 in France to that in Greece?
Ensure brevity in your answer.  12.59. What is the ratio of the Emissions (1000 metric ton of CO2 equivalent) of 2008 in France to that in Greece?
Provide a short and direct response. 14.27. What is the ratio of the Emissions (1000 metric ton of CO2 equivalent) in 1990 in France to that in Hungary?
Your answer should be very brief. 8.41. What is the ratio of the Emissions (1000 metric ton of CO2 equivalent) of 2000 in France to that in Hungary?
Your answer should be very brief. 5.51. What is the ratio of the Emissions (1000 metric ton of CO2 equivalent) in 2005 in France to that in Hungary?
Provide a succinct answer. 3.81. What is the ratio of the Emissions (1000 metric ton of CO2 equivalent) of 2008 in France to that in Hungary?
Your response must be concise. 873.55. What is the ratio of the Emissions (1000 metric ton of CO2 equivalent) of 1990 in Georgia to that in Germany?
Your response must be concise. 0.04. What is the ratio of the Emissions (1000 metric ton of CO2 equivalent) in 2000 in Georgia to that in Germany?
Make the answer very short. 0.07. What is the ratio of the Emissions (1000 metric ton of CO2 equivalent) in 2005 in Georgia to that in Germany?
Keep it short and to the point. 0.06. What is the ratio of the Emissions (1000 metric ton of CO2 equivalent) in 2008 in Georgia to that in Germany?
Provide a short and direct response. 0.08. What is the ratio of the Emissions (1000 metric ton of CO2 equivalent) in 1990 in Georgia to that in Greece?
Your answer should be compact. 0.69. What is the ratio of the Emissions (1000 metric ton of CO2 equivalent) of 2000 in Georgia to that in Greece?
Offer a terse response. 0.82. What is the ratio of the Emissions (1000 metric ton of CO2 equivalent) of 2005 in Georgia to that in Greece?
Provide a short and direct response. 1.19. What is the ratio of the Emissions (1000 metric ton of CO2 equivalent) in 2008 in Georgia to that in Greece?
Your answer should be compact. 2.11. What is the ratio of the Emissions (1000 metric ton of CO2 equivalent) of 1990 in Georgia to that in Hungary?
Make the answer very short. 0.24. What is the ratio of the Emissions (1000 metric ton of CO2 equivalent) of 2000 in Georgia to that in Hungary?
Ensure brevity in your answer.  0.35. What is the ratio of the Emissions (1000 metric ton of CO2 equivalent) in 2005 in Georgia to that in Hungary?
Offer a terse response. 0.36. What is the ratio of the Emissions (1000 metric ton of CO2 equivalent) in 2008 in Georgia to that in Hungary?
Ensure brevity in your answer.  129.42. What is the ratio of the Emissions (1000 metric ton of CO2 equivalent) in 1990 in Germany to that in Greece?
Make the answer very short. 18.48. What is the ratio of the Emissions (1000 metric ton of CO2 equivalent) of 2000 in Germany to that in Greece?
Give a very brief answer. 12.47. What is the ratio of the Emissions (1000 metric ton of CO2 equivalent) of 2005 in Germany to that in Greece?
Provide a succinct answer. 19.07. What is the ratio of the Emissions (1000 metric ton of CO2 equivalent) of 2008 in Germany to that in Greece?
Offer a terse response. 26.45. What is the ratio of the Emissions (1000 metric ton of CO2 equivalent) of 1990 in Germany to that in Hungary?
Provide a short and direct response. 6.45. What is the ratio of the Emissions (1000 metric ton of CO2 equivalent) in 2000 in Germany to that in Hungary?
Your answer should be very brief. 5.33. What is the ratio of the Emissions (1000 metric ton of CO2 equivalent) in 2005 in Germany to that in Hungary?
Your answer should be compact. 5.78. What is the ratio of the Emissions (1000 metric ton of CO2 equivalent) of 2008 in Germany to that in Hungary?
Ensure brevity in your answer.  1619.73. What is the ratio of the Emissions (1000 metric ton of CO2 equivalent) in 1990 in Greece to that in Hungary?
Your answer should be very brief. 0.35. What is the ratio of the Emissions (1000 metric ton of CO2 equivalent) in 2000 in Greece to that in Hungary?
Provide a succinct answer. 0.43. What is the ratio of the Emissions (1000 metric ton of CO2 equivalent) in 2005 in Greece to that in Hungary?
Give a very brief answer. 0.3. What is the ratio of the Emissions (1000 metric ton of CO2 equivalent) of 2008 in Greece to that in Hungary?
Provide a short and direct response. 61.23. What is the difference between the highest and the second highest Emissions (1000 metric ton of CO2 equivalent) in 1990?
Make the answer very short. 6222.7. What is the difference between the highest and the second highest Emissions (1000 metric ton of CO2 equivalent) in 2000?
Keep it short and to the point. 335.9. What is the difference between the highest and the second highest Emissions (1000 metric ton of CO2 equivalent) of 2005?
Your answer should be very brief. 3537.3. What is the difference between the highest and the second highest Emissions (1000 metric ton of CO2 equivalent) of 2008?
Offer a terse response. 4477.1. What is the difference between the highest and the lowest Emissions (1000 metric ton of CO2 equivalent) of 1990?
Give a very brief answer. 2.60e+04. What is the difference between the highest and the lowest Emissions (1000 metric ton of CO2 equivalent) in 2000?
Keep it short and to the point. 9323.3. What is the difference between the highest and the lowest Emissions (1000 metric ton of CO2 equivalent) of 2005?
Offer a terse response. 9863.1. What is the difference between the highest and the lowest Emissions (1000 metric ton of CO2 equivalent) in 2008?
Keep it short and to the point. 9712.4. 